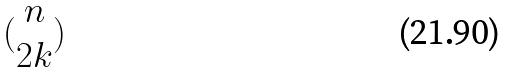<formula> <loc_0><loc_0><loc_500><loc_500>( \begin{matrix} n \\ 2 k \end{matrix} )</formula> 